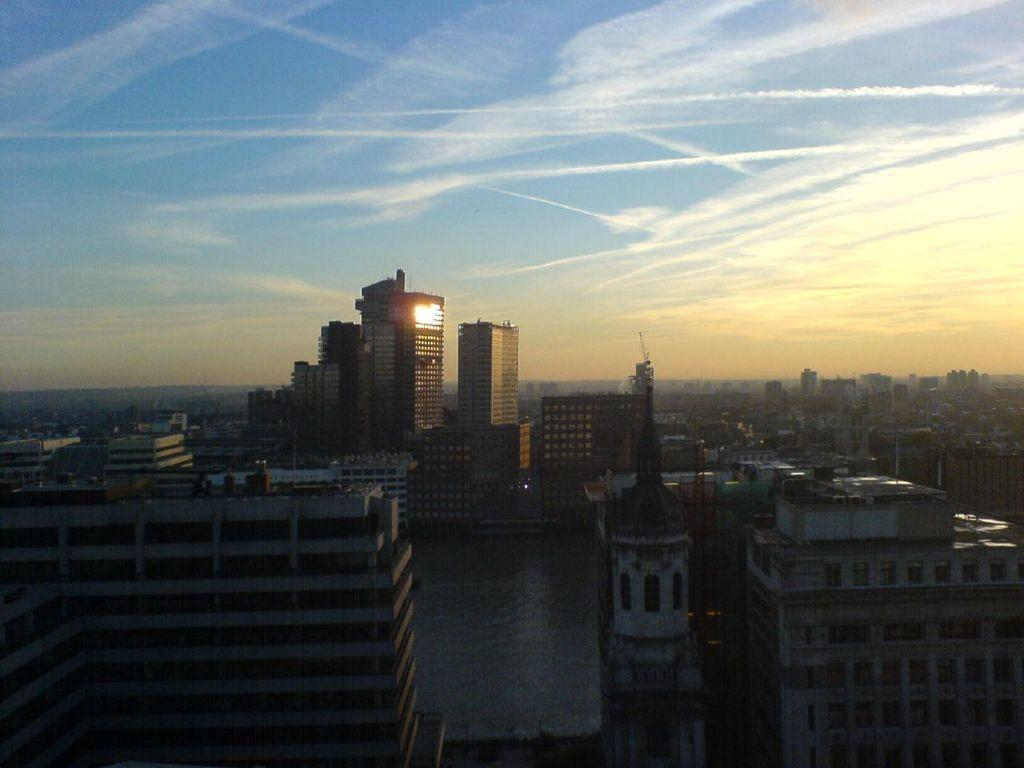What type of structures can be seen in the image? There are buildings in the image. What is the condition of the sky in the image? The sky is blue and cloudy in the image. What type of wax is being used by the family in the image? There is no family or wax present in the image; it only features buildings and a blue and cloudy sky. 